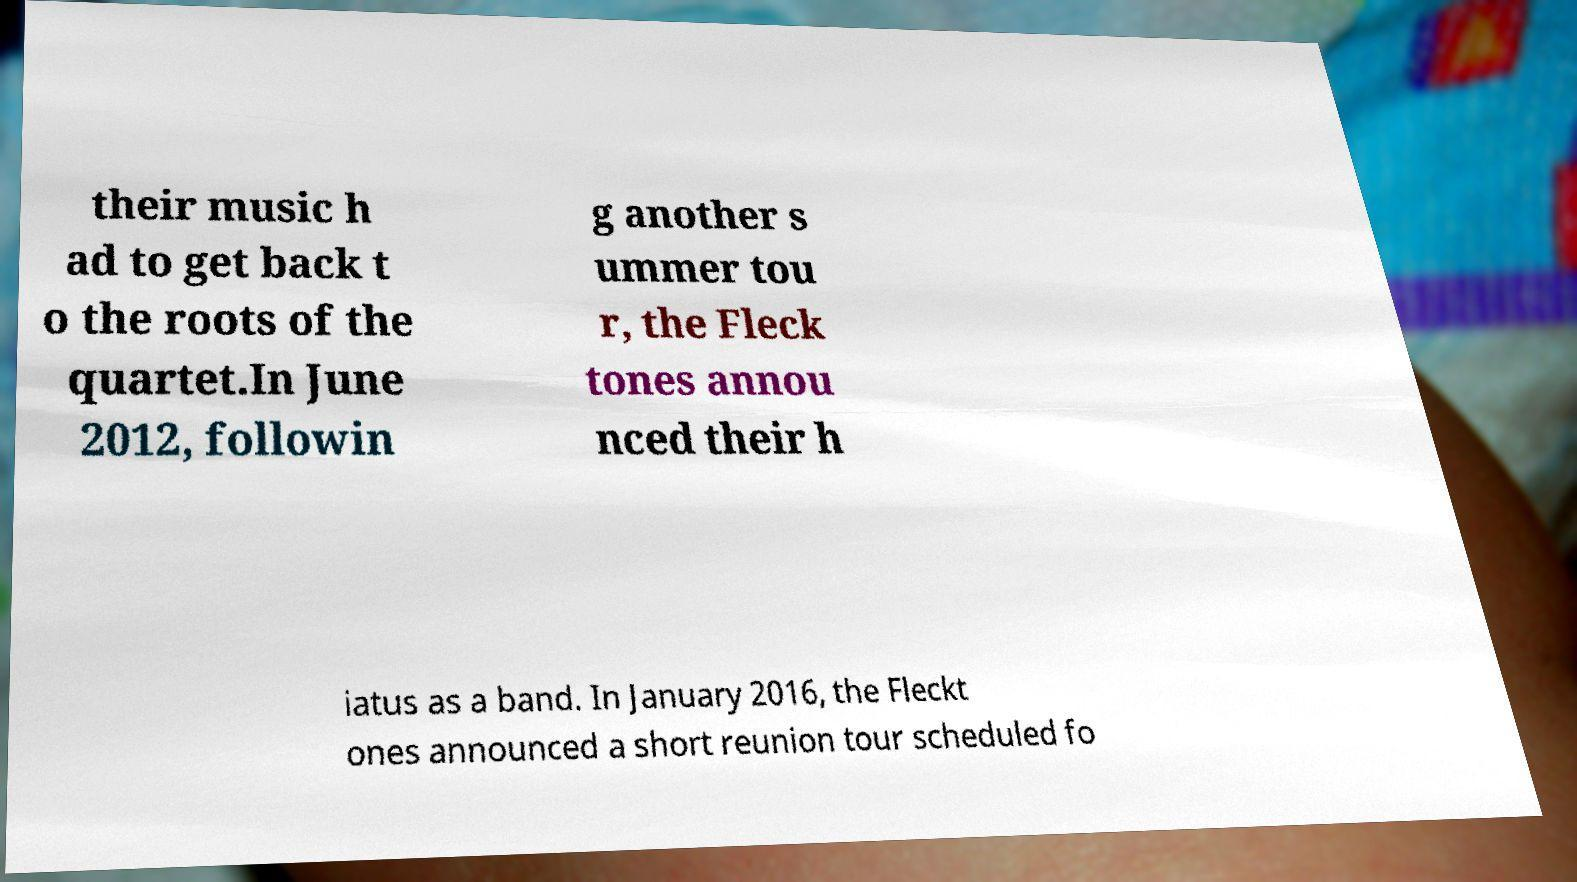Could you extract and type out the text from this image? their music h ad to get back t o the roots of the quartet.In June 2012, followin g another s ummer tou r, the Fleck tones annou nced their h iatus as a band. In January 2016, the Fleckt ones announced a short reunion tour scheduled fo 